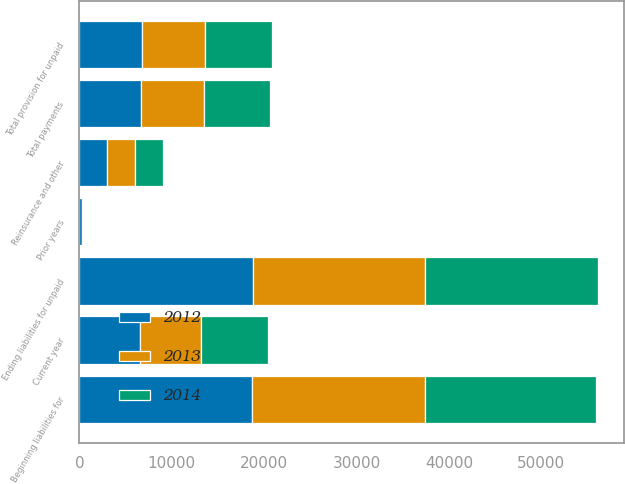<chart> <loc_0><loc_0><loc_500><loc_500><stacked_bar_chart><ecel><fcel>Beginning liabilities for<fcel>Reinsurance and other<fcel>Current year<fcel>Prior years<fcel>Total provision for unpaid<fcel>Total payments<fcel>Ending liabilities for unpaid<nl><fcel>2012<fcel>18676<fcel>3028<fcel>6572<fcel>228<fcel>6800<fcel>6711<fcel>18765<nl><fcel>2013<fcel>18689<fcel>3027<fcel>6621<fcel>192<fcel>6813<fcel>6826<fcel>18676<nl><fcel>2014<fcel>18517<fcel>3033<fcel>7274<fcel>4<fcel>7270<fcel>7098<fcel>18689<nl></chart> 